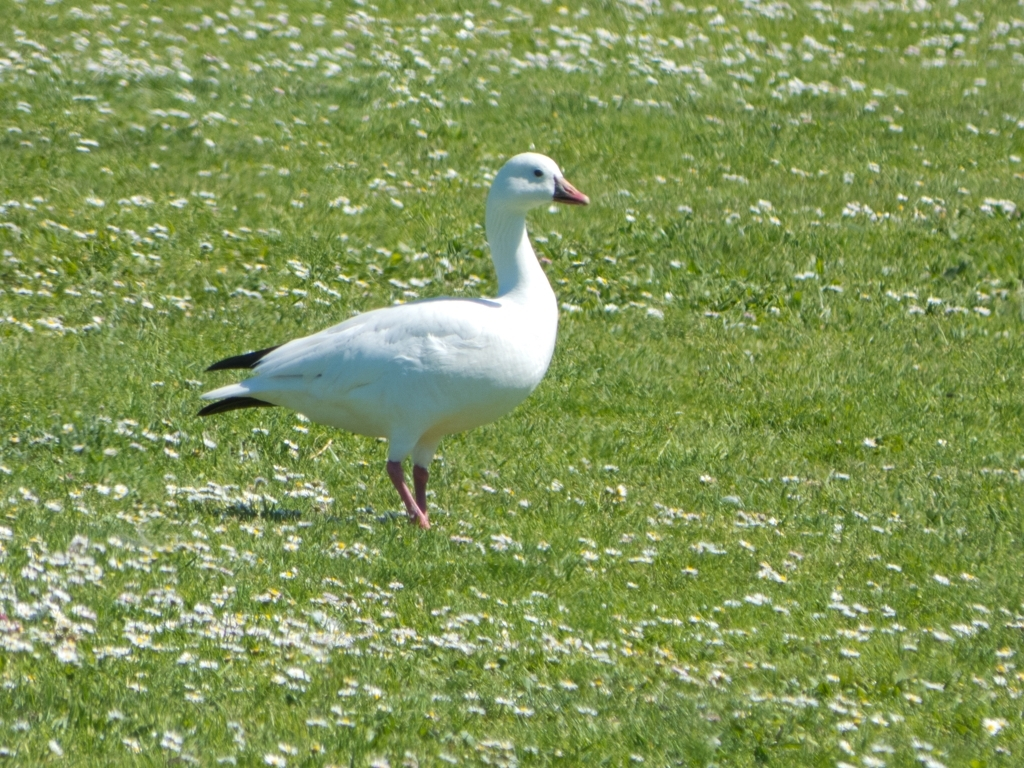What time of year do you think this photo was taken? Judging by the green grass speckled with flowers, it's likely this photo was taken during spring or early summer, when such environments are common in temperate regions where geese might be found. What are the flowers visible around the bird? The white flowers scattered across the grass resemble common daisies, which often bloom during the spring and early summer, adding to the likelihood that this image was captured during those seasons. 